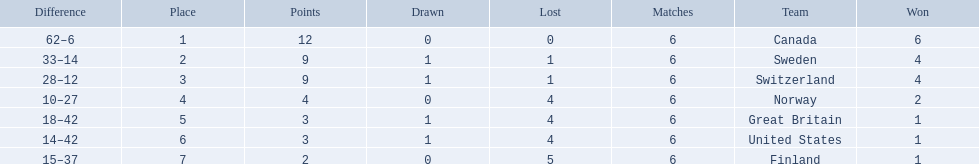What are the names of the countries? Canada, Sweden, Switzerland, Norway, Great Britain, United States, Finland. How many wins did switzerland have? 4. How many wins did great britain have? 1. Which country had more wins, great britain or switzerland? Switzerland. 